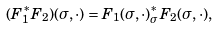Convert formula to latex. <formula><loc_0><loc_0><loc_500><loc_500>( F _ { 1 } ^ { * } F _ { 2 } ) ( \sigma , \cdot ) = F _ { 1 } ( \sigma , \cdot ) ^ { * } _ { \sigma } F _ { 2 } ( \sigma , \cdot ) ,</formula> 